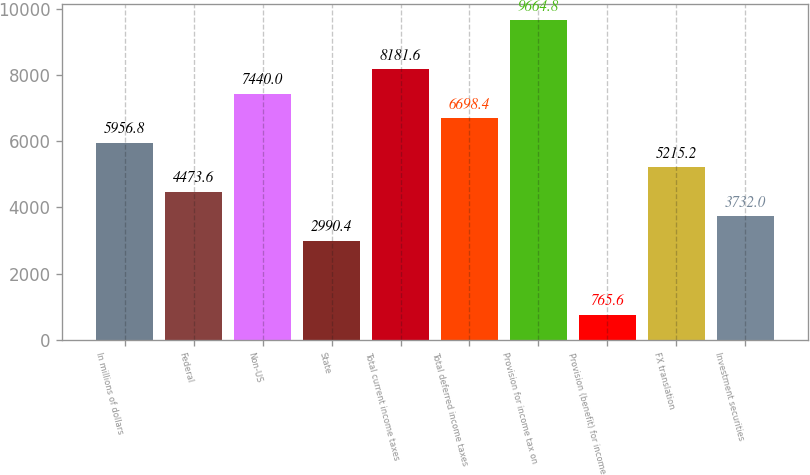<chart> <loc_0><loc_0><loc_500><loc_500><bar_chart><fcel>In millions of dollars<fcel>Federal<fcel>Non-US<fcel>State<fcel>Total current income taxes<fcel>Total deferred income taxes<fcel>Provision for income tax on<fcel>Provision (benefit) for income<fcel>FX translation<fcel>Investment securities<nl><fcel>5956.8<fcel>4473.6<fcel>7440<fcel>2990.4<fcel>8181.6<fcel>6698.4<fcel>9664.8<fcel>765.6<fcel>5215.2<fcel>3732<nl></chart> 